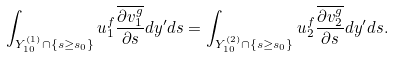<formula> <loc_0><loc_0><loc_500><loc_500>\int _ { Y _ { 1 0 } ^ { ( 1 ) } \cap \{ s \geq s _ { 0 } \} } u _ { 1 } ^ { f } \frac { \overline { \partial v _ { 1 } ^ { g } } } { \partial s } d y ^ { \prime } d s = \int _ { Y _ { 1 0 } ^ { ( 2 ) } \cap \{ s \geq s _ { 0 } \} } u _ { 2 } ^ { f } \frac { \overline { \partial v _ { 2 } ^ { g } } } { \partial s } d y ^ { \prime } d s .</formula> 